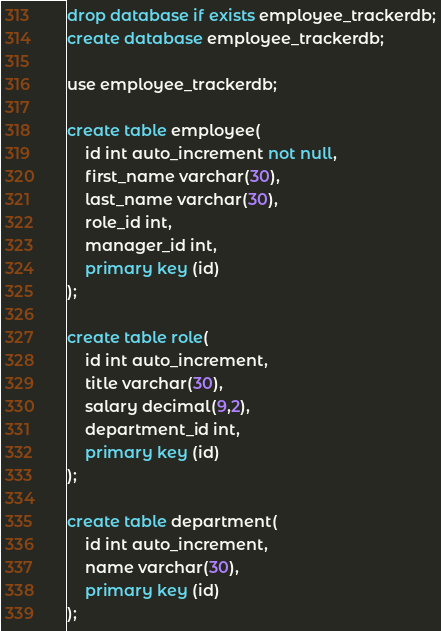Convert code to text. <code><loc_0><loc_0><loc_500><loc_500><_SQL_>drop database if exists employee_trackerdb;
create database employee_trackerdb;

use employee_trackerdb;

create table employee(
	id int auto_increment not null,
    first_name varchar(30),
    last_name varchar(30),
    role_id int,
    manager_id int,
    primary key (id)
);

create table role(
	id int auto_increment,
    title varchar(30),
    salary decimal(9,2),
    department_id int,
    primary key (id)
);

create table department(
	id int auto_increment,
    name varchar(30),
    primary key (id)
);</code> 